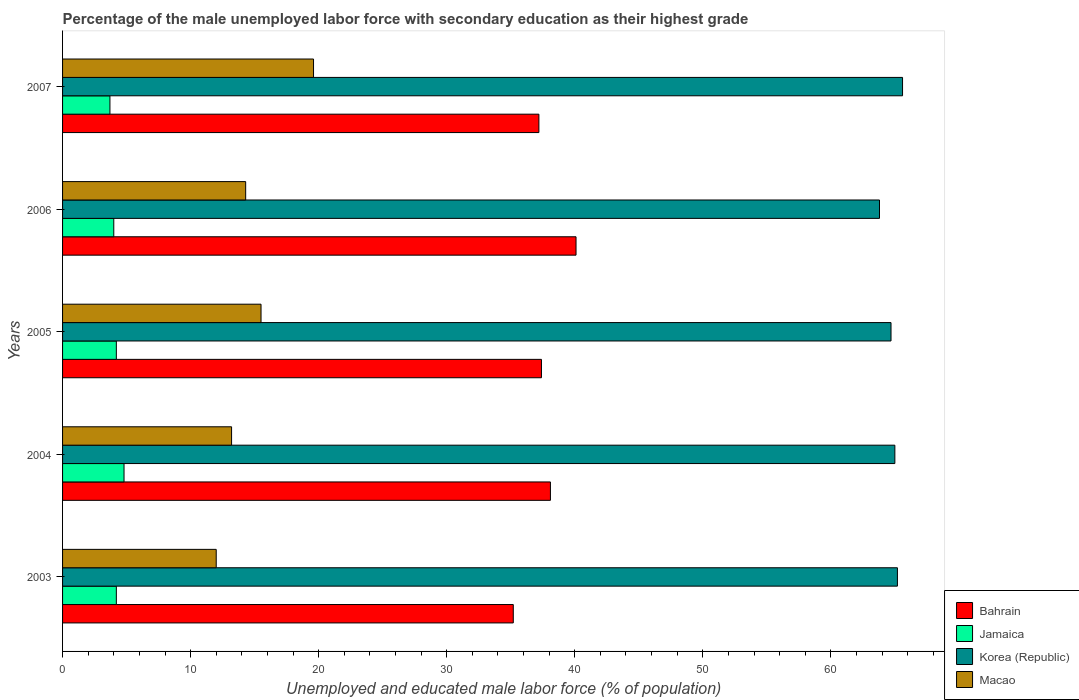How many different coloured bars are there?
Give a very brief answer. 4. How many bars are there on the 1st tick from the bottom?
Make the answer very short. 4. What is the percentage of the unemployed male labor force with secondary education in Macao in 2006?
Keep it short and to the point. 14.3. Across all years, what is the maximum percentage of the unemployed male labor force with secondary education in Korea (Republic)?
Give a very brief answer. 65.6. Across all years, what is the minimum percentage of the unemployed male labor force with secondary education in Bahrain?
Keep it short and to the point. 35.2. What is the total percentage of the unemployed male labor force with secondary education in Jamaica in the graph?
Keep it short and to the point. 20.9. What is the difference between the percentage of the unemployed male labor force with secondary education in Bahrain in 2006 and that in 2007?
Provide a succinct answer. 2.9. What is the average percentage of the unemployed male labor force with secondary education in Korea (Republic) per year?
Give a very brief answer. 64.86. In the year 2003, what is the difference between the percentage of the unemployed male labor force with secondary education in Korea (Republic) and percentage of the unemployed male labor force with secondary education in Jamaica?
Ensure brevity in your answer.  61. What is the ratio of the percentage of the unemployed male labor force with secondary education in Macao in 2003 to that in 2004?
Offer a very short reply. 0.91. Is the percentage of the unemployed male labor force with secondary education in Jamaica in 2003 less than that in 2006?
Give a very brief answer. No. What is the difference between the highest and the second highest percentage of the unemployed male labor force with secondary education in Bahrain?
Ensure brevity in your answer.  2. What is the difference between the highest and the lowest percentage of the unemployed male labor force with secondary education in Korea (Republic)?
Provide a short and direct response. 1.8. In how many years, is the percentage of the unemployed male labor force with secondary education in Korea (Republic) greater than the average percentage of the unemployed male labor force with secondary education in Korea (Republic) taken over all years?
Keep it short and to the point. 3. Is the sum of the percentage of the unemployed male labor force with secondary education in Jamaica in 2004 and 2007 greater than the maximum percentage of the unemployed male labor force with secondary education in Korea (Republic) across all years?
Your response must be concise. No. What does the 2nd bar from the top in 2003 represents?
Provide a short and direct response. Korea (Republic). What does the 1st bar from the bottom in 2005 represents?
Keep it short and to the point. Bahrain. How many bars are there?
Your answer should be very brief. 20. Are all the bars in the graph horizontal?
Your response must be concise. Yes. How many years are there in the graph?
Give a very brief answer. 5. What is the difference between two consecutive major ticks on the X-axis?
Keep it short and to the point. 10. Does the graph contain any zero values?
Your answer should be compact. No. Where does the legend appear in the graph?
Your response must be concise. Bottom right. How many legend labels are there?
Give a very brief answer. 4. What is the title of the graph?
Your answer should be compact. Percentage of the male unemployed labor force with secondary education as their highest grade. Does "Czech Republic" appear as one of the legend labels in the graph?
Make the answer very short. No. What is the label or title of the X-axis?
Your answer should be compact. Unemployed and educated male labor force (% of population). What is the label or title of the Y-axis?
Provide a succinct answer. Years. What is the Unemployed and educated male labor force (% of population) of Bahrain in 2003?
Your answer should be compact. 35.2. What is the Unemployed and educated male labor force (% of population) in Jamaica in 2003?
Your answer should be compact. 4.2. What is the Unemployed and educated male labor force (% of population) of Korea (Republic) in 2003?
Provide a short and direct response. 65.2. What is the Unemployed and educated male labor force (% of population) of Bahrain in 2004?
Your answer should be very brief. 38.1. What is the Unemployed and educated male labor force (% of population) of Jamaica in 2004?
Keep it short and to the point. 4.8. What is the Unemployed and educated male labor force (% of population) in Macao in 2004?
Ensure brevity in your answer.  13.2. What is the Unemployed and educated male labor force (% of population) in Bahrain in 2005?
Keep it short and to the point. 37.4. What is the Unemployed and educated male labor force (% of population) of Jamaica in 2005?
Offer a terse response. 4.2. What is the Unemployed and educated male labor force (% of population) in Korea (Republic) in 2005?
Give a very brief answer. 64.7. What is the Unemployed and educated male labor force (% of population) of Macao in 2005?
Keep it short and to the point. 15.5. What is the Unemployed and educated male labor force (% of population) of Bahrain in 2006?
Offer a terse response. 40.1. What is the Unemployed and educated male labor force (% of population) of Jamaica in 2006?
Ensure brevity in your answer.  4. What is the Unemployed and educated male labor force (% of population) in Korea (Republic) in 2006?
Make the answer very short. 63.8. What is the Unemployed and educated male labor force (% of population) of Macao in 2006?
Provide a short and direct response. 14.3. What is the Unemployed and educated male labor force (% of population) of Bahrain in 2007?
Give a very brief answer. 37.2. What is the Unemployed and educated male labor force (% of population) in Jamaica in 2007?
Provide a short and direct response. 3.7. What is the Unemployed and educated male labor force (% of population) in Korea (Republic) in 2007?
Your answer should be very brief. 65.6. What is the Unemployed and educated male labor force (% of population) in Macao in 2007?
Offer a very short reply. 19.6. Across all years, what is the maximum Unemployed and educated male labor force (% of population) in Bahrain?
Give a very brief answer. 40.1. Across all years, what is the maximum Unemployed and educated male labor force (% of population) in Jamaica?
Your answer should be compact. 4.8. Across all years, what is the maximum Unemployed and educated male labor force (% of population) of Korea (Republic)?
Your answer should be very brief. 65.6. Across all years, what is the maximum Unemployed and educated male labor force (% of population) in Macao?
Your response must be concise. 19.6. Across all years, what is the minimum Unemployed and educated male labor force (% of population) in Bahrain?
Your response must be concise. 35.2. Across all years, what is the minimum Unemployed and educated male labor force (% of population) in Jamaica?
Offer a very short reply. 3.7. Across all years, what is the minimum Unemployed and educated male labor force (% of population) of Korea (Republic)?
Ensure brevity in your answer.  63.8. What is the total Unemployed and educated male labor force (% of population) in Bahrain in the graph?
Provide a short and direct response. 188. What is the total Unemployed and educated male labor force (% of population) in Jamaica in the graph?
Offer a very short reply. 20.9. What is the total Unemployed and educated male labor force (% of population) in Korea (Republic) in the graph?
Provide a succinct answer. 324.3. What is the total Unemployed and educated male labor force (% of population) of Macao in the graph?
Offer a terse response. 74.6. What is the difference between the Unemployed and educated male labor force (% of population) in Bahrain in 2003 and that in 2004?
Your answer should be compact. -2.9. What is the difference between the Unemployed and educated male labor force (% of population) of Korea (Republic) in 2003 and that in 2004?
Provide a succinct answer. 0.2. What is the difference between the Unemployed and educated male labor force (% of population) of Macao in 2003 and that in 2005?
Offer a terse response. -3.5. What is the difference between the Unemployed and educated male labor force (% of population) in Bahrain in 2003 and that in 2006?
Your response must be concise. -4.9. What is the difference between the Unemployed and educated male labor force (% of population) of Korea (Republic) in 2003 and that in 2006?
Offer a very short reply. 1.4. What is the difference between the Unemployed and educated male labor force (% of population) in Macao in 2003 and that in 2006?
Your response must be concise. -2.3. What is the difference between the Unemployed and educated male labor force (% of population) in Jamaica in 2003 and that in 2007?
Your response must be concise. 0.5. What is the difference between the Unemployed and educated male labor force (% of population) in Bahrain in 2004 and that in 2005?
Your answer should be compact. 0.7. What is the difference between the Unemployed and educated male labor force (% of population) in Korea (Republic) in 2004 and that in 2005?
Your answer should be compact. 0.3. What is the difference between the Unemployed and educated male labor force (% of population) of Macao in 2004 and that in 2005?
Provide a succinct answer. -2.3. What is the difference between the Unemployed and educated male labor force (% of population) of Bahrain in 2004 and that in 2006?
Give a very brief answer. -2. What is the difference between the Unemployed and educated male labor force (% of population) in Korea (Republic) in 2004 and that in 2006?
Make the answer very short. 1.2. What is the difference between the Unemployed and educated male labor force (% of population) in Bahrain in 2004 and that in 2007?
Keep it short and to the point. 0.9. What is the difference between the Unemployed and educated male labor force (% of population) in Macao in 2004 and that in 2007?
Your answer should be very brief. -6.4. What is the difference between the Unemployed and educated male labor force (% of population) of Jamaica in 2005 and that in 2006?
Your response must be concise. 0.2. What is the difference between the Unemployed and educated male labor force (% of population) of Korea (Republic) in 2005 and that in 2006?
Ensure brevity in your answer.  0.9. What is the difference between the Unemployed and educated male labor force (% of population) in Macao in 2005 and that in 2006?
Keep it short and to the point. 1.2. What is the difference between the Unemployed and educated male labor force (% of population) in Jamaica in 2005 and that in 2007?
Provide a short and direct response. 0.5. What is the difference between the Unemployed and educated male labor force (% of population) of Korea (Republic) in 2005 and that in 2007?
Give a very brief answer. -0.9. What is the difference between the Unemployed and educated male labor force (% of population) in Jamaica in 2006 and that in 2007?
Make the answer very short. 0.3. What is the difference between the Unemployed and educated male labor force (% of population) in Bahrain in 2003 and the Unemployed and educated male labor force (% of population) in Jamaica in 2004?
Your answer should be very brief. 30.4. What is the difference between the Unemployed and educated male labor force (% of population) of Bahrain in 2003 and the Unemployed and educated male labor force (% of population) of Korea (Republic) in 2004?
Provide a succinct answer. -29.8. What is the difference between the Unemployed and educated male labor force (% of population) of Jamaica in 2003 and the Unemployed and educated male labor force (% of population) of Korea (Republic) in 2004?
Provide a short and direct response. -60.8. What is the difference between the Unemployed and educated male labor force (% of population) of Jamaica in 2003 and the Unemployed and educated male labor force (% of population) of Macao in 2004?
Make the answer very short. -9. What is the difference between the Unemployed and educated male labor force (% of population) of Korea (Republic) in 2003 and the Unemployed and educated male labor force (% of population) of Macao in 2004?
Your answer should be compact. 52. What is the difference between the Unemployed and educated male labor force (% of population) in Bahrain in 2003 and the Unemployed and educated male labor force (% of population) in Jamaica in 2005?
Keep it short and to the point. 31. What is the difference between the Unemployed and educated male labor force (% of population) of Bahrain in 2003 and the Unemployed and educated male labor force (% of population) of Korea (Republic) in 2005?
Offer a terse response. -29.5. What is the difference between the Unemployed and educated male labor force (% of population) in Jamaica in 2003 and the Unemployed and educated male labor force (% of population) in Korea (Republic) in 2005?
Your answer should be compact. -60.5. What is the difference between the Unemployed and educated male labor force (% of population) of Korea (Republic) in 2003 and the Unemployed and educated male labor force (% of population) of Macao in 2005?
Provide a short and direct response. 49.7. What is the difference between the Unemployed and educated male labor force (% of population) in Bahrain in 2003 and the Unemployed and educated male labor force (% of population) in Jamaica in 2006?
Offer a very short reply. 31.2. What is the difference between the Unemployed and educated male labor force (% of population) in Bahrain in 2003 and the Unemployed and educated male labor force (% of population) in Korea (Republic) in 2006?
Your answer should be very brief. -28.6. What is the difference between the Unemployed and educated male labor force (% of population) in Bahrain in 2003 and the Unemployed and educated male labor force (% of population) in Macao in 2006?
Your answer should be very brief. 20.9. What is the difference between the Unemployed and educated male labor force (% of population) in Jamaica in 2003 and the Unemployed and educated male labor force (% of population) in Korea (Republic) in 2006?
Make the answer very short. -59.6. What is the difference between the Unemployed and educated male labor force (% of population) of Korea (Republic) in 2003 and the Unemployed and educated male labor force (% of population) of Macao in 2006?
Your response must be concise. 50.9. What is the difference between the Unemployed and educated male labor force (% of population) of Bahrain in 2003 and the Unemployed and educated male labor force (% of population) of Jamaica in 2007?
Keep it short and to the point. 31.5. What is the difference between the Unemployed and educated male labor force (% of population) in Bahrain in 2003 and the Unemployed and educated male labor force (% of population) in Korea (Republic) in 2007?
Your answer should be compact. -30.4. What is the difference between the Unemployed and educated male labor force (% of population) in Bahrain in 2003 and the Unemployed and educated male labor force (% of population) in Macao in 2007?
Your response must be concise. 15.6. What is the difference between the Unemployed and educated male labor force (% of population) of Jamaica in 2003 and the Unemployed and educated male labor force (% of population) of Korea (Republic) in 2007?
Offer a very short reply. -61.4. What is the difference between the Unemployed and educated male labor force (% of population) of Jamaica in 2003 and the Unemployed and educated male labor force (% of population) of Macao in 2007?
Keep it short and to the point. -15.4. What is the difference between the Unemployed and educated male labor force (% of population) of Korea (Republic) in 2003 and the Unemployed and educated male labor force (% of population) of Macao in 2007?
Your answer should be compact. 45.6. What is the difference between the Unemployed and educated male labor force (% of population) of Bahrain in 2004 and the Unemployed and educated male labor force (% of population) of Jamaica in 2005?
Your answer should be very brief. 33.9. What is the difference between the Unemployed and educated male labor force (% of population) of Bahrain in 2004 and the Unemployed and educated male labor force (% of population) of Korea (Republic) in 2005?
Keep it short and to the point. -26.6. What is the difference between the Unemployed and educated male labor force (% of population) in Bahrain in 2004 and the Unemployed and educated male labor force (% of population) in Macao in 2005?
Offer a very short reply. 22.6. What is the difference between the Unemployed and educated male labor force (% of population) in Jamaica in 2004 and the Unemployed and educated male labor force (% of population) in Korea (Republic) in 2005?
Ensure brevity in your answer.  -59.9. What is the difference between the Unemployed and educated male labor force (% of population) of Jamaica in 2004 and the Unemployed and educated male labor force (% of population) of Macao in 2005?
Offer a terse response. -10.7. What is the difference between the Unemployed and educated male labor force (% of population) in Korea (Republic) in 2004 and the Unemployed and educated male labor force (% of population) in Macao in 2005?
Ensure brevity in your answer.  49.5. What is the difference between the Unemployed and educated male labor force (% of population) of Bahrain in 2004 and the Unemployed and educated male labor force (% of population) of Jamaica in 2006?
Provide a succinct answer. 34.1. What is the difference between the Unemployed and educated male labor force (% of population) in Bahrain in 2004 and the Unemployed and educated male labor force (% of population) in Korea (Republic) in 2006?
Provide a short and direct response. -25.7. What is the difference between the Unemployed and educated male labor force (% of population) of Bahrain in 2004 and the Unemployed and educated male labor force (% of population) of Macao in 2006?
Offer a very short reply. 23.8. What is the difference between the Unemployed and educated male labor force (% of population) in Jamaica in 2004 and the Unemployed and educated male labor force (% of population) in Korea (Republic) in 2006?
Provide a short and direct response. -59. What is the difference between the Unemployed and educated male labor force (% of population) of Korea (Republic) in 2004 and the Unemployed and educated male labor force (% of population) of Macao in 2006?
Provide a short and direct response. 50.7. What is the difference between the Unemployed and educated male labor force (% of population) in Bahrain in 2004 and the Unemployed and educated male labor force (% of population) in Jamaica in 2007?
Your answer should be compact. 34.4. What is the difference between the Unemployed and educated male labor force (% of population) of Bahrain in 2004 and the Unemployed and educated male labor force (% of population) of Korea (Republic) in 2007?
Offer a terse response. -27.5. What is the difference between the Unemployed and educated male labor force (% of population) in Jamaica in 2004 and the Unemployed and educated male labor force (% of population) in Korea (Republic) in 2007?
Make the answer very short. -60.8. What is the difference between the Unemployed and educated male labor force (% of population) in Jamaica in 2004 and the Unemployed and educated male labor force (% of population) in Macao in 2007?
Offer a very short reply. -14.8. What is the difference between the Unemployed and educated male labor force (% of population) in Korea (Republic) in 2004 and the Unemployed and educated male labor force (% of population) in Macao in 2007?
Your answer should be compact. 45.4. What is the difference between the Unemployed and educated male labor force (% of population) in Bahrain in 2005 and the Unemployed and educated male labor force (% of population) in Jamaica in 2006?
Give a very brief answer. 33.4. What is the difference between the Unemployed and educated male labor force (% of population) of Bahrain in 2005 and the Unemployed and educated male labor force (% of population) of Korea (Republic) in 2006?
Offer a terse response. -26.4. What is the difference between the Unemployed and educated male labor force (% of population) of Bahrain in 2005 and the Unemployed and educated male labor force (% of population) of Macao in 2006?
Give a very brief answer. 23.1. What is the difference between the Unemployed and educated male labor force (% of population) in Jamaica in 2005 and the Unemployed and educated male labor force (% of population) in Korea (Republic) in 2006?
Offer a very short reply. -59.6. What is the difference between the Unemployed and educated male labor force (% of population) in Korea (Republic) in 2005 and the Unemployed and educated male labor force (% of population) in Macao in 2006?
Provide a succinct answer. 50.4. What is the difference between the Unemployed and educated male labor force (% of population) in Bahrain in 2005 and the Unemployed and educated male labor force (% of population) in Jamaica in 2007?
Keep it short and to the point. 33.7. What is the difference between the Unemployed and educated male labor force (% of population) in Bahrain in 2005 and the Unemployed and educated male labor force (% of population) in Korea (Republic) in 2007?
Ensure brevity in your answer.  -28.2. What is the difference between the Unemployed and educated male labor force (% of population) in Jamaica in 2005 and the Unemployed and educated male labor force (% of population) in Korea (Republic) in 2007?
Offer a terse response. -61.4. What is the difference between the Unemployed and educated male labor force (% of population) in Jamaica in 2005 and the Unemployed and educated male labor force (% of population) in Macao in 2007?
Offer a terse response. -15.4. What is the difference between the Unemployed and educated male labor force (% of population) of Korea (Republic) in 2005 and the Unemployed and educated male labor force (% of population) of Macao in 2007?
Ensure brevity in your answer.  45.1. What is the difference between the Unemployed and educated male labor force (% of population) of Bahrain in 2006 and the Unemployed and educated male labor force (% of population) of Jamaica in 2007?
Your answer should be very brief. 36.4. What is the difference between the Unemployed and educated male labor force (% of population) of Bahrain in 2006 and the Unemployed and educated male labor force (% of population) of Korea (Republic) in 2007?
Keep it short and to the point. -25.5. What is the difference between the Unemployed and educated male labor force (% of population) in Jamaica in 2006 and the Unemployed and educated male labor force (% of population) in Korea (Republic) in 2007?
Provide a succinct answer. -61.6. What is the difference between the Unemployed and educated male labor force (% of population) in Jamaica in 2006 and the Unemployed and educated male labor force (% of population) in Macao in 2007?
Your response must be concise. -15.6. What is the difference between the Unemployed and educated male labor force (% of population) of Korea (Republic) in 2006 and the Unemployed and educated male labor force (% of population) of Macao in 2007?
Your answer should be very brief. 44.2. What is the average Unemployed and educated male labor force (% of population) in Bahrain per year?
Your answer should be compact. 37.6. What is the average Unemployed and educated male labor force (% of population) of Jamaica per year?
Keep it short and to the point. 4.18. What is the average Unemployed and educated male labor force (% of population) in Korea (Republic) per year?
Give a very brief answer. 64.86. What is the average Unemployed and educated male labor force (% of population) of Macao per year?
Ensure brevity in your answer.  14.92. In the year 2003, what is the difference between the Unemployed and educated male labor force (% of population) of Bahrain and Unemployed and educated male labor force (% of population) of Jamaica?
Your response must be concise. 31. In the year 2003, what is the difference between the Unemployed and educated male labor force (% of population) in Bahrain and Unemployed and educated male labor force (% of population) in Korea (Republic)?
Make the answer very short. -30. In the year 2003, what is the difference between the Unemployed and educated male labor force (% of population) in Bahrain and Unemployed and educated male labor force (% of population) in Macao?
Ensure brevity in your answer.  23.2. In the year 2003, what is the difference between the Unemployed and educated male labor force (% of population) of Jamaica and Unemployed and educated male labor force (% of population) of Korea (Republic)?
Your response must be concise. -61. In the year 2003, what is the difference between the Unemployed and educated male labor force (% of population) of Korea (Republic) and Unemployed and educated male labor force (% of population) of Macao?
Give a very brief answer. 53.2. In the year 2004, what is the difference between the Unemployed and educated male labor force (% of population) in Bahrain and Unemployed and educated male labor force (% of population) in Jamaica?
Make the answer very short. 33.3. In the year 2004, what is the difference between the Unemployed and educated male labor force (% of population) in Bahrain and Unemployed and educated male labor force (% of population) in Korea (Republic)?
Make the answer very short. -26.9. In the year 2004, what is the difference between the Unemployed and educated male labor force (% of population) of Bahrain and Unemployed and educated male labor force (% of population) of Macao?
Your answer should be very brief. 24.9. In the year 2004, what is the difference between the Unemployed and educated male labor force (% of population) in Jamaica and Unemployed and educated male labor force (% of population) in Korea (Republic)?
Make the answer very short. -60.2. In the year 2004, what is the difference between the Unemployed and educated male labor force (% of population) of Jamaica and Unemployed and educated male labor force (% of population) of Macao?
Your response must be concise. -8.4. In the year 2004, what is the difference between the Unemployed and educated male labor force (% of population) of Korea (Republic) and Unemployed and educated male labor force (% of population) of Macao?
Provide a short and direct response. 51.8. In the year 2005, what is the difference between the Unemployed and educated male labor force (% of population) of Bahrain and Unemployed and educated male labor force (% of population) of Jamaica?
Provide a succinct answer. 33.2. In the year 2005, what is the difference between the Unemployed and educated male labor force (% of population) in Bahrain and Unemployed and educated male labor force (% of population) in Korea (Republic)?
Provide a short and direct response. -27.3. In the year 2005, what is the difference between the Unemployed and educated male labor force (% of population) in Bahrain and Unemployed and educated male labor force (% of population) in Macao?
Give a very brief answer. 21.9. In the year 2005, what is the difference between the Unemployed and educated male labor force (% of population) in Jamaica and Unemployed and educated male labor force (% of population) in Korea (Republic)?
Keep it short and to the point. -60.5. In the year 2005, what is the difference between the Unemployed and educated male labor force (% of population) in Korea (Republic) and Unemployed and educated male labor force (% of population) in Macao?
Offer a very short reply. 49.2. In the year 2006, what is the difference between the Unemployed and educated male labor force (% of population) in Bahrain and Unemployed and educated male labor force (% of population) in Jamaica?
Ensure brevity in your answer.  36.1. In the year 2006, what is the difference between the Unemployed and educated male labor force (% of population) of Bahrain and Unemployed and educated male labor force (% of population) of Korea (Republic)?
Your response must be concise. -23.7. In the year 2006, what is the difference between the Unemployed and educated male labor force (% of population) in Bahrain and Unemployed and educated male labor force (% of population) in Macao?
Provide a short and direct response. 25.8. In the year 2006, what is the difference between the Unemployed and educated male labor force (% of population) of Jamaica and Unemployed and educated male labor force (% of population) of Korea (Republic)?
Make the answer very short. -59.8. In the year 2006, what is the difference between the Unemployed and educated male labor force (% of population) of Jamaica and Unemployed and educated male labor force (% of population) of Macao?
Provide a short and direct response. -10.3. In the year 2006, what is the difference between the Unemployed and educated male labor force (% of population) in Korea (Republic) and Unemployed and educated male labor force (% of population) in Macao?
Offer a terse response. 49.5. In the year 2007, what is the difference between the Unemployed and educated male labor force (% of population) of Bahrain and Unemployed and educated male labor force (% of population) of Jamaica?
Provide a short and direct response. 33.5. In the year 2007, what is the difference between the Unemployed and educated male labor force (% of population) of Bahrain and Unemployed and educated male labor force (% of population) of Korea (Republic)?
Offer a terse response. -28.4. In the year 2007, what is the difference between the Unemployed and educated male labor force (% of population) in Jamaica and Unemployed and educated male labor force (% of population) in Korea (Republic)?
Provide a succinct answer. -61.9. In the year 2007, what is the difference between the Unemployed and educated male labor force (% of population) in Jamaica and Unemployed and educated male labor force (% of population) in Macao?
Keep it short and to the point. -15.9. In the year 2007, what is the difference between the Unemployed and educated male labor force (% of population) in Korea (Republic) and Unemployed and educated male labor force (% of population) in Macao?
Offer a terse response. 46. What is the ratio of the Unemployed and educated male labor force (% of population) of Bahrain in 2003 to that in 2004?
Ensure brevity in your answer.  0.92. What is the ratio of the Unemployed and educated male labor force (% of population) of Korea (Republic) in 2003 to that in 2004?
Offer a terse response. 1. What is the ratio of the Unemployed and educated male labor force (% of population) in Macao in 2003 to that in 2004?
Offer a terse response. 0.91. What is the ratio of the Unemployed and educated male labor force (% of population) of Bahrain in 2003 to that in 2005?
Offer a terse response. 0.94. What is the ratio of the Unemployed and educated male labor force (% of population) in Korea (Republic) in 2003 to that in 2005?
Your response must be concise. 1.01. What is the ratio of the Unemployed and educated male labor force (% of population) in Macao in 2003 to that in 2005?
Give a very brief answer. 0.77. What is the ratio of the Unemployed and educated male labor force (% of population) of Bahrain in 2003 to that in 2006?
Give a very brief answer. 0.88. What is the ratio of the Unemployed and educated male labor force (% of population) in Jamaica in 2003 to that in 2006?
Make the answer very short. 1.05. What is the ratio of the Unemployed and educated male labor force (% of population) in Korea (Republic) in 2003 to that in 2006?
Offer a very short reply. 1.02. What is the ratio of the Unemployed and educated male labor force (% of population) in Macao in 2003 to that in 2006?
Give a very brief answer. 0.84. What is the ratio of the Unemployed and educated male labor force (% of population) in Bahrain in 2003 to that in 2007?
Make the answer very short. 0.95. What is the ratio of the Unemployed and educated male labor force (% of population) in Jamaica in 2003 to that in 2007?
Make the answer very short. 1.14. What is the ratio of the Unemployed and educated male labor force (% of population) of Korea (Republic) in 2003 to that in 2007?
Provide a short and direct response. 0.99. What is the ratio of the Unemployed and educated male labor force (% of population) of Macao in 2003 to that in 2007?
Provide a succinct answer. 0.61. What is the ratio of the Unemployed and educated male labor force (% of population) in Bahrain in 2004 to that in 2005?
Give a very brief answer. 1.02. What is the ratio of the Unemployed and educated male labor force (% of population) of Korea (Republic) in 2004 to that in 2005?
Your response must be concise. 1. What is the ratio of the Unemployed and educated male labor force (% of population) in Macao in 2004 to that in 2005?
Ensure brevity in your answer.  0.85. What is the ratio of the Unemployed and educated male labor force (% of population) in Bahrain in 2004 to that in 2006?
Keep it short and to the point. 0.95. What is the ratio of the Unemployed and educated male labor force (% of population) of Jamaica in 2004 to that in 2006?
Keep it short and to the point. 1.2. What is the ratio of the Unemployed and educated male labor force (% of population) of Korea (Republic) in 2004 to that in 2006?
Provide a succinct answer. 1.02. What is the ratio of the Unemployed and educated male labor force (% of population) of Bahrain in 2004 to that in 2007?
Provide a succinct answer. 1.02. What is the ratio of the Unemployed and educated male labor force (% of population) in Jamaica in 2004 to that in 2007?
Your answer should be very brief. 1.3. What is the ratio of the Unemployed and educated male labor force (% of population) in Korea (Republic) in 2004 to that in 2007?
Your answer should be very brief. 0.99. What is the ratio of the Unemployed and educated male labor force (% of population) in Macao in 2004 to that in 2007?
Give a very brief answer. 0.67. What is the ratio of the Unemployed and educated male labor force (% of population) in Bahrain in 2005 to that in 2006?
Give a very brief answer. 0.93. What is the ratio of the Unemployed and educated male labor force (% of population) in Korea (Republic) in 2005 to that in 2006?
Provide a short and direct response. 1.01. What is the ratio of the Unemployed and educated male labor force (% of population) in Macao in 2005 to that in 2006?
Your answer should be compact. 1.08. What is the ratio of the Unemployed and educated male labor force (% of population) of Bahrain in 2005 to that in 2007?
Provide a succinct answer. 1.01. What is the ratio of the Unemployed and educated male labor force (% of population) of Jamaica in 2005 to that in 2007?
Provide a succinct answer. 1.14. What is the ratio of the Unemployed and educated male labor force (% of population) of Korea (Republic) in 2005 to that in 2007?
Your answer should be compact. 0.99. What is the ratio of the Unemployed and educated male labor force (% of population) in Macao in 2005 to that in 2007?
Your answer should be compact. 0.79. What is the ratio of the Unemployed and educated male labor force (% of population) in Bahrain in 2006 to that in 2007?
Provide a short and direct response. 1.08. What is the ratio of the Unemployed and educated male labor force (% of population) of Jamaica in 2006 to that in 2007?
Give a very brief answer. 1.08. What is the ratio of the Unemployed and educated male labor force (% of population) of Korea (Republic) in 2006 to that in 2007?
Give a very brief answer. 0.97. What is the ratio of the Unemployed and educated male labor force (% of population) in Macao in 2006 to that in 2007?
Your answer should be very brief. 0.73. What is the difference between the highest and the second highest Unemployed and educated male labor force (% of population) in Jamaica?
Offer a terse response. 0.6. What is the difference between the highest and the lowest Unemployed and educated male labor force (% of population) in Bahrain?
Your answer should be very brief. 4.9. What is the difference between the highest and the lowest Unemployed and educated male labor force (% of population) in Korea (Republic)?
Your answer should be very brief. 1.8. 